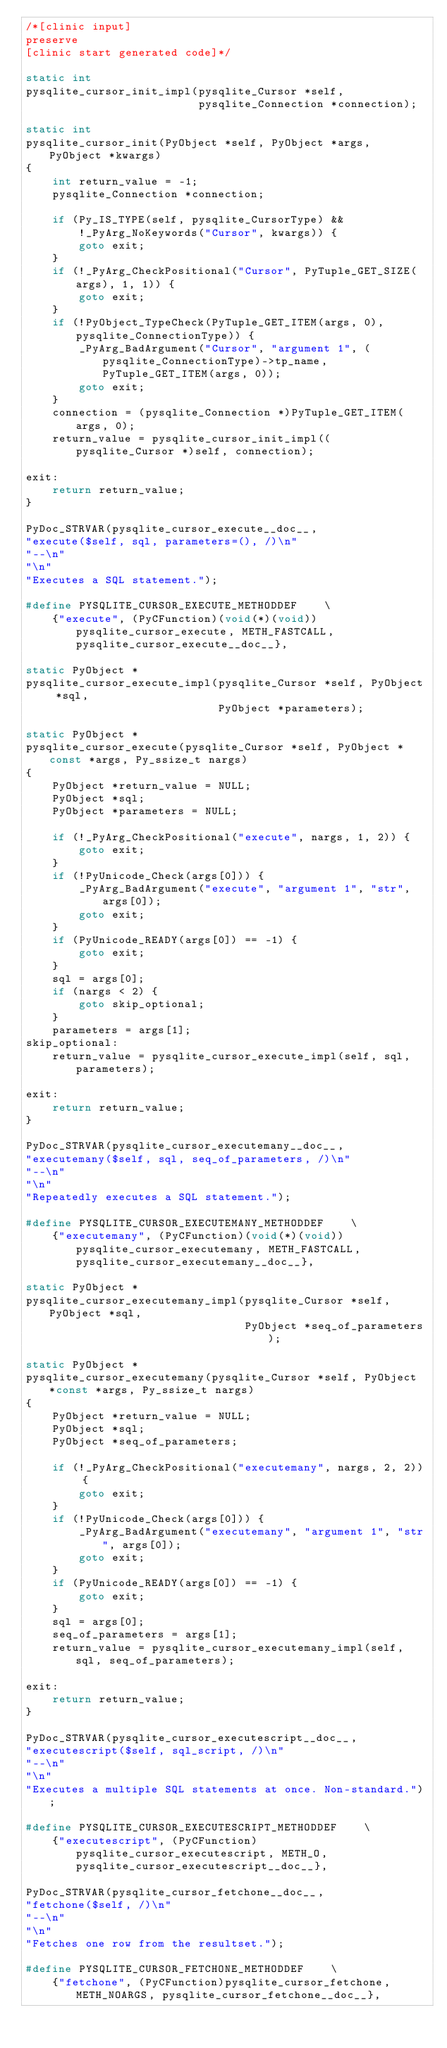Convert code to text. <code><loc_0><loc_0><loc_500><loc_500><_C_>/*[clinic input]
preserve
[clinic start generated code]*/

static int
pysqlite_cursor_init_impl(pysqlite_Cursor *self,
                          pysqlite_Connection *connection);

static int
pysqlite_cursor_init(PyObject *self, PyObject *args, PyObject *kwargs)
{
    int return_value = -1;
    pysqlite_Connection *connection;

    if (Py_IS_TYPE(self, pysqlite_CursorType) &&
        !_PyArg_NoKeywords("Cursor", kwargs)) {
        goto exit;
    }
    if (!_PyArg_CheckPositional("Cursor", PyTuple_GET_SIZE(args), 1, 1)) {
        goto exit;
    }
    if (!PyObject_TypeCheck(PyTuple_GET_ITEM(args, 0), pysqlite_ConnectionType)) {
        _PyArg_BadArgument("Cursor", "argument 1", (pysqlite_ConnectionType)->tp_name, PyTuple_GET_ITEM(args, 0));
        goto exit;
    }
    connection = (pysqlite_Connection *)PyTuple_GET_ITEM(args, 0);
    return_value = pysqlite_cursor_init_impl((pysqlite_Cursor *)self, connection);

exit:
    return return_value;
}

PyDoc_STRVAR(pysqlite_cursor_execute__doc__,
"execute($self, sql, parameters=(), /)\n"
"--\n"
"\n"
"Executes a SQL statement.");

#define PYSQLITE_CURSOR_EXECUTE_METHODDEF    \
    {"execute", (PyCFunction)(void(*)(void))pysqlite_cursor_execute, METH_FASTCALL, pysqlite_cursor_execute__doc__},

static PyObject *
pysqlite_cursor_execute_impl(pysqlite_Cursor *self, PyObject *sql,
                             PyObject *parameters);

static PyObject *
pysqlite_cursor_execute(pysqlite_Cursor *self, PyObject *const *args, Py_ssize_t nargs)
{
    PyObject *return_value = NULL;
    PyObject *sql;
    PyObject *parameters = NULL;

    if (!_PyArg_CheckPositional("execute", nargs, 1, 2)) {
        goto exit;
    }
    if (!PyUnicode_Check(args[0])) {
        _PyArg_BadArgument("execute", "argument 1", "str", args[0]);
        goto exit;
    }
    if (PyUnicode_READY(args[0]) == -1) {
        goto exit;
    }
    sql = args[0];
    if (nargs < 2) {
        goto skip_optional;
    }
    parameters = args[1];
skip_optional:
    return_value = pysqlite_cursor_execute_impl(self, sql, parameters);

exit:
    return return_value;
}

PyDoc_STRVAR(pysqlite_cursor_executemany__doc__,
"executemany($self, sql, seq_of_parameters, /)\n"
"--\n"
"\n"
"Repeatedly executes a SQL statement.");

#define PYSQLITE_CURSOR_EXECUTEMANY_METHODDEF    \
    {"executemany", (PyCFunction)(void(*)(void))pysqlite_cursor_executemany, METH_FASTCALL, pysqlite_cursor_executemany__doc__},

static PyObject *
pysqlite_cursor_executemany_impl(pysqlite_Cursor *self, PyObject *sql,
                                 PyObject *seq_of_parameters);

static PyObject *
pysqlite_cursor_executemany(pysqlite_Cursor *self, PyObject *const *args, Py_ssize_t nargs)
{
    PyObject *return_value = NULL;
    PyObject *sql;
    PyObject *seq_of_parameters;

    if (!_PyArg_CheckPositional("executemany", nargs, 2, 2)) {
        goto exit;
    }
    if (!PyUnicode_Check(args[0])) {
        _PyArg_BadArgument("executemany", "argument 1", "str", args[0]);
        goto exit;
    }
    if (PyUnicode_READY(args[0]) == -1) {
        goto exit;
    }
    sql = args[0];
    seq_of_parameters = args[1];
    return_value = pysqlite_cursor_executemany_impl(self, sql, seq_of_parameters);

exit:
    return return_value;
}

PyDoc_STRVAR(pysqlite_cursor_executescript__doc__,
"executescript($self, sql_script, /)\n"
"--\n"
"\n"
"Executes a multiple SQL statements at once. Non-standard.");

#define PYSQLITE_CURSOR_EXECUTESCRIPT_METHODDEF    \
    {"executescript", (PyCFunction)pysqlite_cursor_executescript, METH_O, pysqlite_cursor_executescript__doc__},

PyDoc_STRVAR(pysqlite_cursor_fetchone__doc__,
"fetchone($self, /)\n"
"--\n"
"\n"
"Fetches one row from the resultset.");

#define PYSQLITE_CURSOR_FETCHONE_METHODDEF    \
    {"fetchone", (PyCFunction)pysqlite_cursor_fetchone, METH_NOARGS, pysqlite_cursor_fetchone__doc__},
</code> 